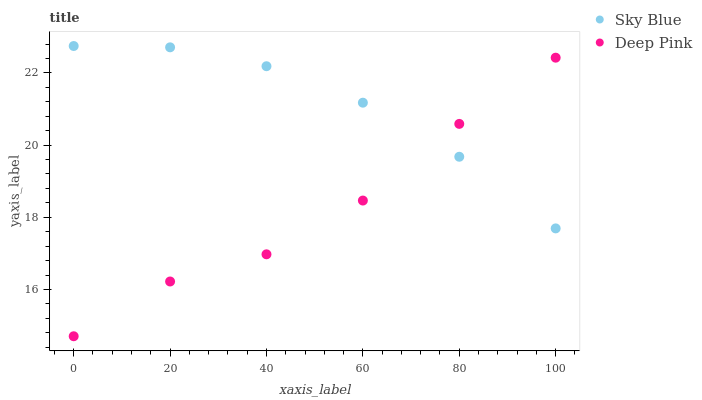Does Deep Pink have the minimum area under the curve?
Answer yes or no. Yes. Does Sky Blue have the maximum area under the curve?
Answer yes or no. Yes. Does Deep Pink have the maximum area under the curve?
Answer yes or no. No. Is Sky Blue the smoothest?
Answer yes or no. Yes. Is Deep Pink the roughest?
Answer yes or no. Yes. Is Deep Pink the smoothest?
Answer yes or no. No. Does Deep Pink have the lowest value?
Answer yes or no. Yes. Does Sky Blue have the highest value?
Answer yes or no. Yes. Does Deep Pink have the highest value?
Answer yes or no. No. Does Sky Blue intersect Deep Pink?
Answer yes or no. Yes. Is Sky Blue less than Deep Pink?
Answer yes or no. No. Is Sky Blue greater than Deep Pink?
Answer yes or no. No. 